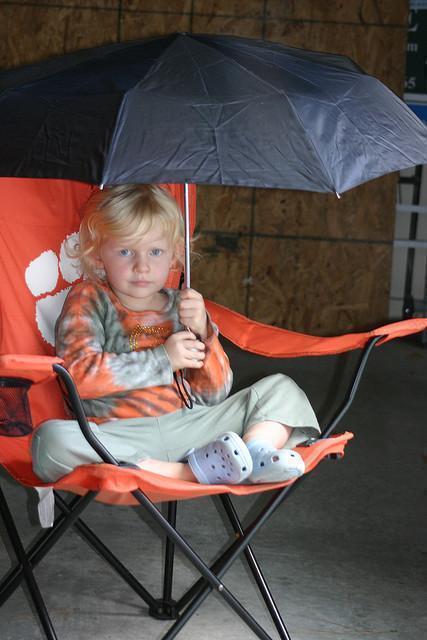What minimalizing action can this chair be made to do?
Choose the correct response, then elucidate: 'Answer: answer
Rationale: rationale.'
Options: Disappear, shrink, blow up, fold up. Answer: fold up.
Rationale: It is a portable chair 